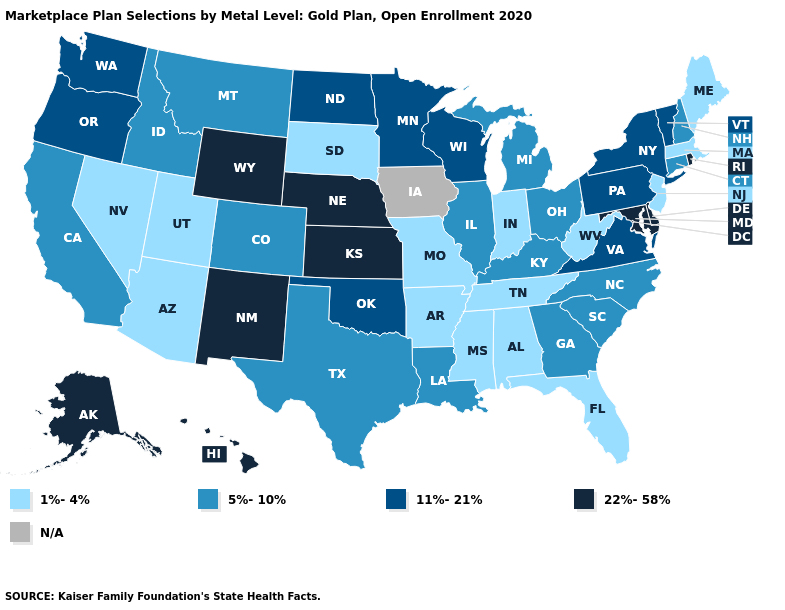Which states have the highest value in the USA?
Give a very brief answer. Alaska, Delaware, Hawaii, Kansas, Maryland, Nebraska, New Mexico, Rhode Island, Wyoming. Does the first symbol in the legend represent the smallest category?
Answer briefly. Yes. What is the highest value in states that border Arizona?
Short answer required. 22%-58%. What is the value of Massachusetts?
Quick response, please. 1%-4%. Does Washington have the highest value in the USA?
Concise answer only. No. Does Georgia have the highest value in the South?
Be succinct. No. Name the states that have a value in the range 22%-58%?
Quick response, please. Alaska, Delaware, Hawaii, Kansas, Maryland, Nebraska, New Mexico, Rhode Island, Wyoming. What is the value of Maryland?
Concise answer only. 22%-58%. What is the lowest value in the South?
Answer briefly. 1%-4%. Which states hav the highest value in the MidWest?
Concise answer only. Kansas, Nebraska. Does the map have missing data?
Concise answer only. Yes. What is the highest value in the West ?
Keep it brief. 22%-58%. What is the lowest value in states that border South Dakota?
Quick response, please. 5%-10%. What is the value of Kansas?
Concise answer only. 22%-58%. 